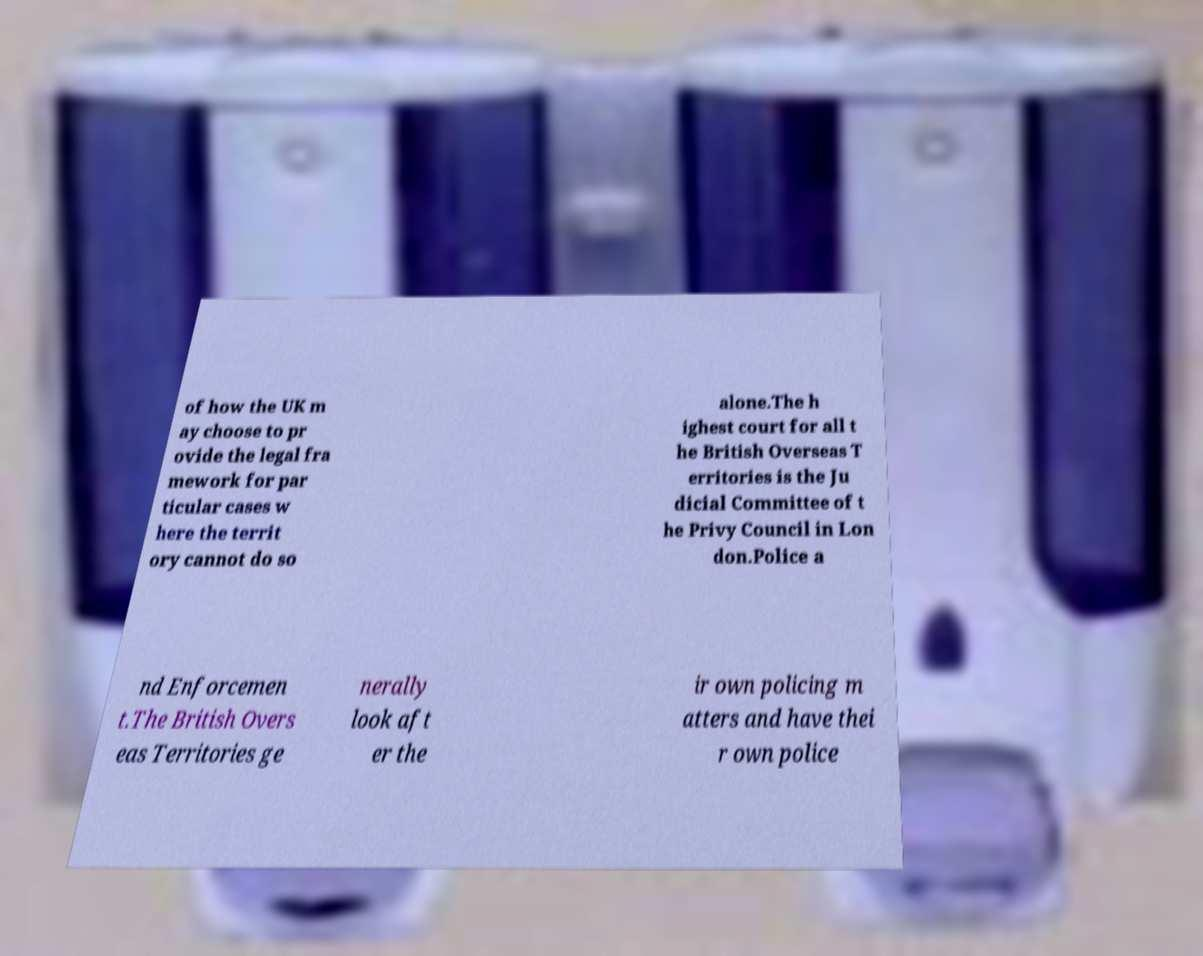There's text embedded in this image that I need extracted. Can you transcribe it verbatim? of how the UK m ay choose to pr ovide the legal fra mework for par ticular cases w here the territ ory cannot do so alone.The h ighest court for all t he British Overseas T erritories is the Ju dicial Committee of t he Privy Council in Lon don.Police a nd Enforcemen t.The British Overs eas Territories ge nerally look aft er the ir own policing m atters and have thei r own police 